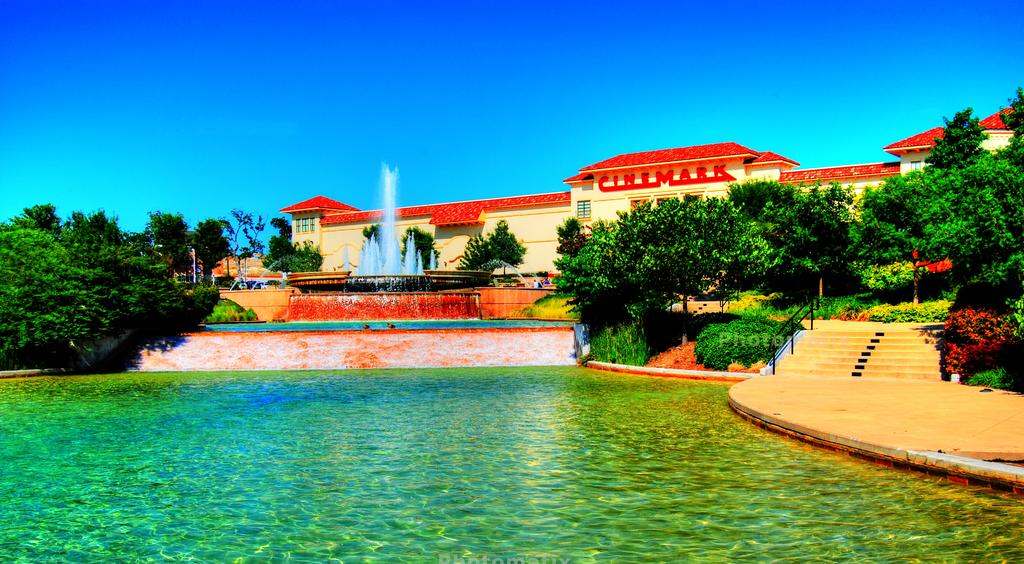What type of natural elements can be seen in the image? There are many trees and plants in the image. What architectural features are present in the image? There are stairs, rods, water fountains, and a walkway in the image. What is the condition of the sky in the image? The sky is clear at the top of the image. Where is the basin located in the image? There is no basin present in the image. What statement is being made by the trees in the image? Trees do not make statements; they are inanimate objects. 